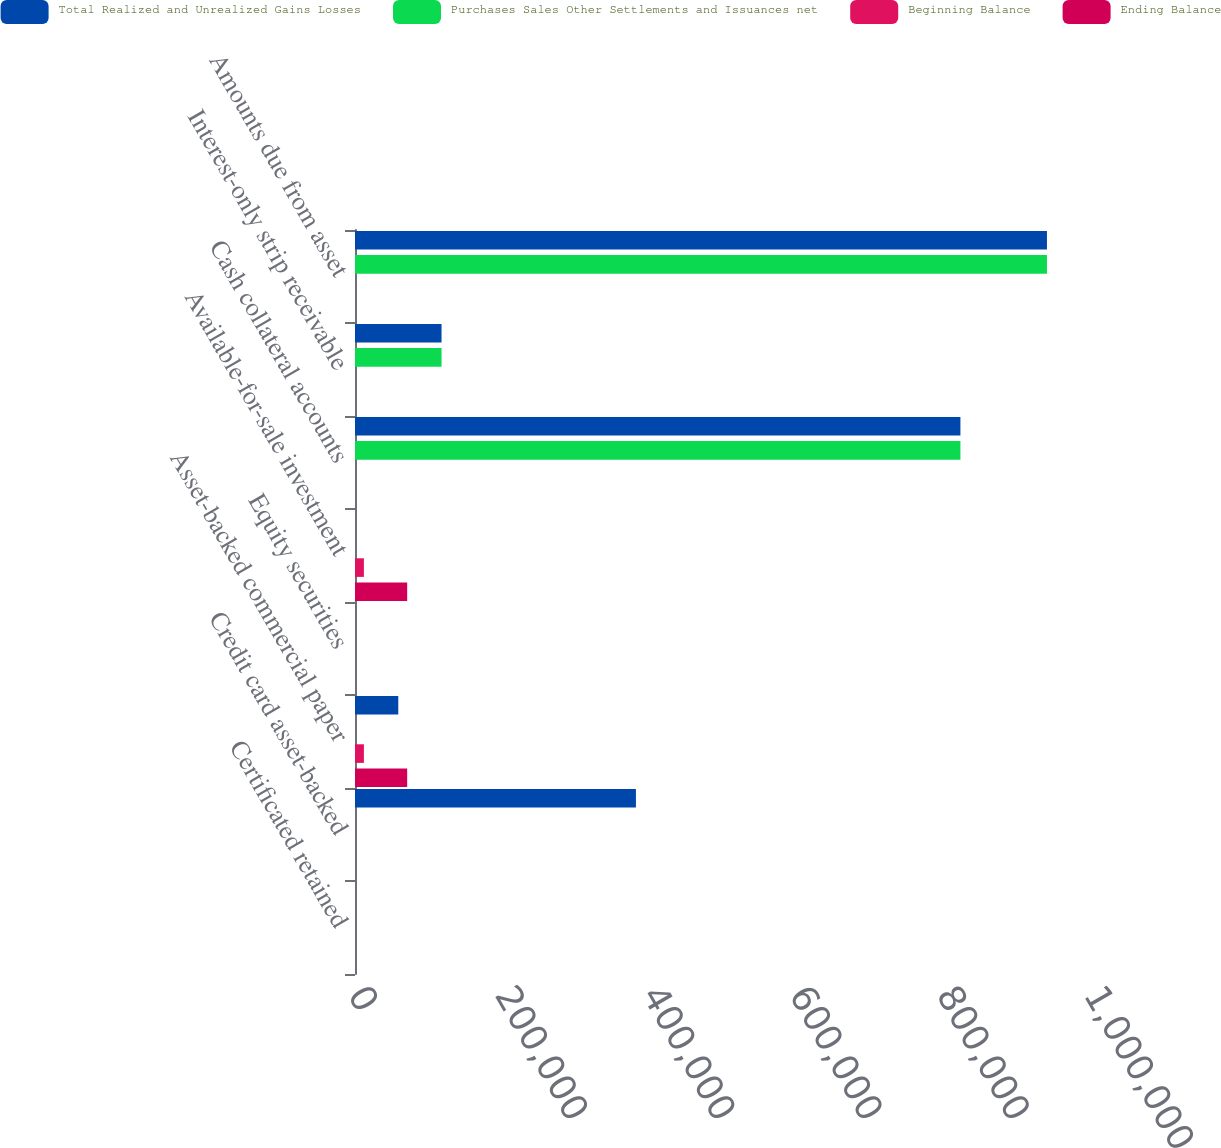Convert chart to OTSL. <chart><loc_0><loc_0><loc_500><loc_500><stacked_bar_chart><ecel><fcel>Certificated retained<fcel>Credit card asset-backed<fcel>Asset-backed commercial paper<fcel>Equity securities<fcel>Available-for-sale investment<fcel>Cash collateral accounts<fcel>Interest-only strip receivable<fcel>Amounts due from asset<nl><fcel>Total Realized and Unrealized Gains Losses<fcel>0<fcel>381705<fcel>58792<fcel>0<fcel>0<fcel>822585<fcel>117579<fcel>940164<nl><fcel>Purchases Sales Other Settlements and Issuances net<fcel>0<fcel>0<fcel>0<fcel>0<fcel>0<fcel>822585<fcel>117579<fcel>940164<nl><fcel>Beginning Balance<fcel>0<fcel>0<fcel>12101<fcel>0<fcel>12101<fcel>0<fcel>0<fcel>0<nl><fcel>Ending Balance<fcel>0<fcel>0<fcel>70893<fcel>0<fcel>70893<fcel>0<fcel>0<fcel>0<nl></chart> 